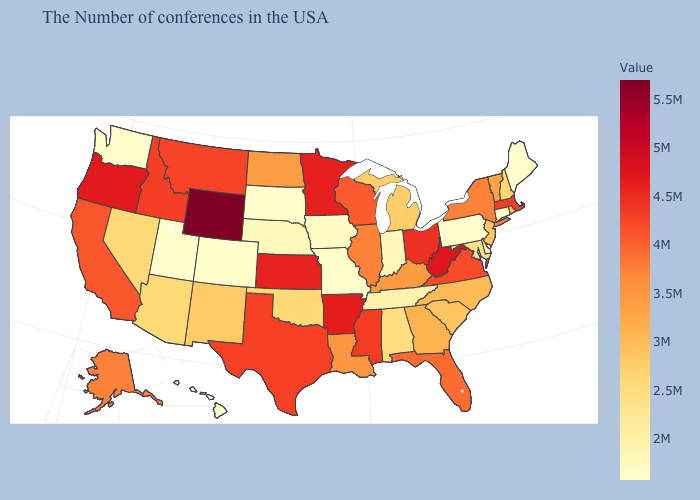Among the states that border Oregon , does Washington have the lowest value?
Write a very short answer. Yes. Among the states that border Vermont , does Massachusetts have the lowest value?
Quick response, please. No. Among the states that border Washington , which have the highest value?
Give a very brief answer. Oregon. Does the map have missing data?
Short answer required. No. Among the states that border New Mexico , which have the highest value?
Keep it brief. Texas. Which states have the lowest value in the West?
Concise answer only. Colorado, Utah, Washington, Hawaii. Among the states that border Vermont , which have the highest value?
Be succinct. Massachusetts. Which states have the lowest value in the Northeast?
Keep it brief. Maine, Connecticut, Pennsylvania. 